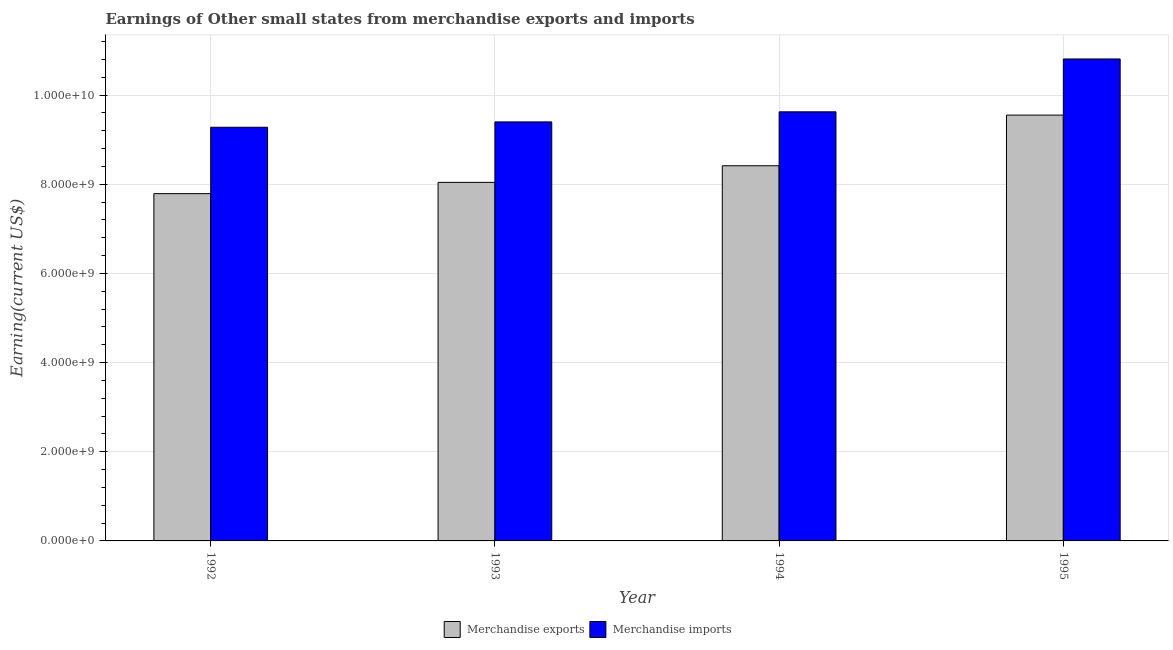How many different coloured bars are there?
Offer a very short reply. 2. How many groups of bars are there?
Ensure brevity in your answer.  4. Are the number of bars per tick equal to the number of legend labels?
Your answer should be compact. Yes. Are the number of bars on each tick of the X-axis equal?
Make the answer very short. Yes. How many bars are there on the 1st tick from the right?
Give a very brief answer. 2. What is the earnings from merchandise exports in 1995?
Your answer should be very brief. 9.55e+09. Across all years, what is the maximum earnings from merchandise exports?
Offer a terse response. 9.55e+09. Across all years, what is the minimum earnings from merchandise imports?
Give a very brief answer. 9.28e+09. What is the total earnings from merchandise imports in the graph?
Give a very brief answer. 3.91e+1. What is the difference between the earnings from merchandise imports in 1993 and that in 1995?
Provide a short and direct response. -1.41e+09. What is the difference between the earnings from merchandise exports in 1992 and the earnings from merchandise imports in 1995?
Ensure brevity in your answer.  -1.76e+09. What is the average earnings from merchandise exports per year?
Your response must be concise. 8.45e+09. In the year 1992, what is the difference between the earnings from merchandise exports and earnings from merchandise imports?
Offer a terse response. 0. What is the ratio of the earnings from merchandise exports in 1992 to that in 1994?
Make the answer very short. 0.93. Is the earnings from merchandise exports in 1992 less than that in 1995?
Provide a succinct answer. Yes. What is the difference between the highest and the second highest earnings from merchandise imports?
Provide a short and direct response. 1.19e+09. What is the difference between the highest and the lowest earnings from merchandise exports?
Give a very brief answer. 1.76e+09. Is the sum of the earnings from merchandise exports in 1992 and 1993 greater than the maximum earnings from merchandise imports across all years?
Your answer should be compact. Yes. What does the 1st bar from the left in 1992 represents?
Make the answer very short. Merchandise exports. What does the 2nd bar from the right in 1993 represents?
Give a very brief answer. Merchandise exports. How many bars are there?
Give a very brief answer. 8. How many years are there in the graph?
Give a very brief answer. 4. What is the difference between two consecutive major ticks on the Y-axis?
Your answer should be very brief. 2.00e+09. Are the values on the major ticks of Y-axis written in scientific E-notation?
Make the answer very short. Yes. Does the graph contain any zero values?
Your response must be concise. No. Where does the legend appear in the graph?
Offer a terse response. Bottom center. How many legend labels are there?
Keep it short and to the point. 2. What is the title of the graph?
Offer a terse response. Earnings of Other small states from merchandise exports and imports. Does "Broad money growth" appear as one of the legend labels in the graph?
Offer a terse response. No. What is the label or title of the Y-axis?
Your answer should be compact. Earning(current US$). What is the Earning(current US$) of Merchandise exports in 1992?
Offer a very short reply. 7.79e+09. What is the Earning(current US$) of Merchandise imports in 1992?
Offer a terse response. 9.28e+09. What is the Earning(current US$) in Merchandise exports in 1993?
Ensure brevity in your answer.  8.04e+09. What is the Earning(current US$) of Merchandise imports in 1993?
Provide a short and direct response. 9.40e+09. What is the Earning(current US$) of Merchandise exports in 1994?
Offer a very short reply. 8.41e+09. What is the Earning(current US$) in Merchandise imports in 1994?
Your response must be concise. 9.62e+09. What is the Earning(current US$) of Merchandise exports in 1995?
Provide a short and direct response. 9.55e+09. What is the Earning(current US$) in Merchandise imports in 1995?
Provide a short and direct response. 1.08e+1. Across all years, what is the maximum Earning(current US$) of Merchandise exports?
Your answer should be compact. 9.55e+09. Across all years, what is the maximum Earning(current US$) of Merchandise imports?
Your answer should be compact. 1.08e+1. Across all years, what is the minimum Earning(current US$) of Merchandise exports?
Give a very brief answer. 7.79e+09. Across all years, what is the minimum Earning(current US$) of Merchandise imports?
Provide a succinct answer. 9.28e+09. What is the total Earning(current US$) of Merchandise exports in the graph?
Provide a short and direct response. 3.38e+1. What is the total Earning(current US$) in Merchandise imports in the graph?
Offer a very short reply. 3.91e+1. What is the difference between the Earning(current US$) in Merchandise exports in 1992 and that in 1993?
Offer a very short reply. -2.53e+08. What is the difference between the Earning(current US$) in Merchandise imports in 1992 and that in 1993?
Ensure brevity in your answer.  -1.20e+08. What is the difference between the Earning(current US$) in Merchandise exports in 1992 and that in 1994?
Your answer should be very brief. -6.25e+08. What is the difference between the Earning(current US$) in Merchandise imports in 1992 and that in 1994?
Offer a terse response. -3.46e+08. What is the difference between the Earning(current US$) in Merchandise exports in 1992 and that in 1995?
Your answer should be very brief. -1.76e+09. What is the difference between the Earning(current US$) of Merchandise imports in 1992 and that in 1995?
Your response must be concise. -1.53e+09. What is the difference between the Earning(current US$) of Merchandise exports in 1993 and that in 1994?
Offer a terse response. -3.72e+08. What is the difference between the Earning(current US$) of Merchandise imports in 1993 and that in 1994?
Your answer should be compact. -2.26e+08. What is the difference between the Earning(current US$) of Merchandise exports in 1993 and that in 1995?
Keep it short and to the point. -1.51e+09. What is the difference between the Earning(current US$) of Merchandise imports in 1993 and that in 1995?
Provide a succinct answer. -1.41e+09. What is the difference between the Earning(current US$) in Merchandise exports in 1994 and that in 1995?
Make the answer very short. -1.14e+09. What is the difference between the Earning(current US$) of Merchandise imports in 1994 and that in 1995?
Your response must be concise. -1.19e+09. What is the difference between the Earning(current US$) in Merchandise exports in 1992 and the Earning(current US$) in Merchandise imports in 1993?
Give a very brief answer. -1.61e+09. What is the difference between the Earning(current US$) of Merchandise exports in 1992 and the Earning(current US$) of Merchandise imports in 1994?
Your answer should be compact. -1.83e+09. What is the difference between the Earning(current US$) in Merchandise exports in 1992 and the Earning(current US$) in Merchandise imports in 1995?
Keep it short and to the point. -3.02e+09. What is the difference between the Earning(current US$) of Merchandise exports in 1993 and the Earning(current US$) of Merchandise imports in 1994?
Your answer should be very brief. -1.58e+09. What is the difference between the Earning(current US$) in Merchandise exports in 1993 and the Earning(current US$) in Merchandise imports in 1995?
Your answer should be very brief. -2.77e+09. What is the difference between the Earning(current US$) of Merchandise exports in 1994 and the Earning(current US$) of Merchandise imports in 1995?
Provide a short and direct response. -2.40e+09. What is the average Earning(current US$) of Merchandise exports per year?
Your response must be concise. 8.45e+09. What is the average Earning(current US$) of Merchandise imports per year?
Provide a short and direct response. 9.78e+09. In the year 1992, what is the difference between the Earning(current US$) of Merchandise exports and Earning(current US$) of Merchandise imports?
Your answer should be compact. -1.49e+09. In the year 1993, what is the difference between the Earning(current US$) in Merchandise exports and Earning(current US$) in Merchandise imports?
Make the answer very short. -1.36e+09. In the year 1994, what is the difference between the Earning(current US$) of Merchandise exports and Earning(current US$) of Merchandise imports?
Offer a terse response. -1.21e+09. In the year 1995, what is the difference between the Earning(current US$) in Merchandise exports and Earning(current US$) in Merchandise imports?
Your response must be concise. -1.26e+09. What is the ratio of the Earning(current US$) in Merchandise exports in 1992 to that in 1993?
Give a very brief answer. 0.97. What is the ratio of the Earning(current US$) in Merchandise imports in 1992 to that in 1993?
Offer a very short reply. 0.99. What is the ratio of the Earning(current US$) of Merchandise exports in 1992 to that in 1994?
Your answer should be compact. 0.93. What is the ratio of the Earning(current US$) of Merchandise imports in 1992 to that in 1994?
Your response must be concise. 0.96. What is the ratio of the Earning(current US$) in Merchandise exports in 1992 to that in 1995?
Your response must be concise. 0.82. What is the ratio of the Earning(current US$) in Merchandise imports in 1992 to that in 1995?
Offer a very short reply. 0.86. What is the ratio of the Earning(current US$) of Merchandise exports in 1993 to that in 1994?
Keep it short and to the point. 0.96. What is the ratio of the Earning(current US$) in Merchandise imports in 1993 to that in 1994?
Offer a very short reply. 0.98. What is the ratio of the Earning(current US$) in Merchandise exports in 1993 to that in 1995?
Give a very brief answer. 0.84. What is the ratio of the Earning(current US$) of Merchandise imports in 1993 to that in 1995?
Offer a very short reply. 0.87. What is the ratio of the Earning(current US$) of Merchandise exports in 1994 to that in 1995?
Ensure brevity in your answer.  0.88. What is the ratio of the Earning(current US$) in Merchandise imports in 1994 to that in 1995?
Provide a short and direct response. 0.89. What is the difference between the highest and the second highest Earning(current US$) in Merchandise exports?
Your response must be concise. 1.14e+09. What is the difference between the highest and the second highest Earning(current US$) of Merchandise imports?
Offer a very short reply. 1.19e+09. What is the difference between the highest and the lowest Earning(current US$) in Merchandise exports?
Your answer should be very brief. 1.76e+09. What is the difference between the highest and the lowest Earning(current US$) of Merchandise imports?
Offer a terse response. 1.53e+09. 